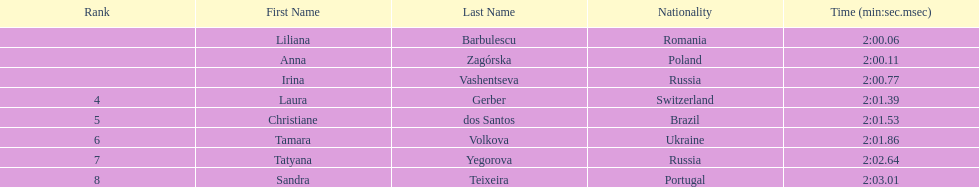What is the name of the top finalist of this semifinals heat? Liliana Barbulescu. 